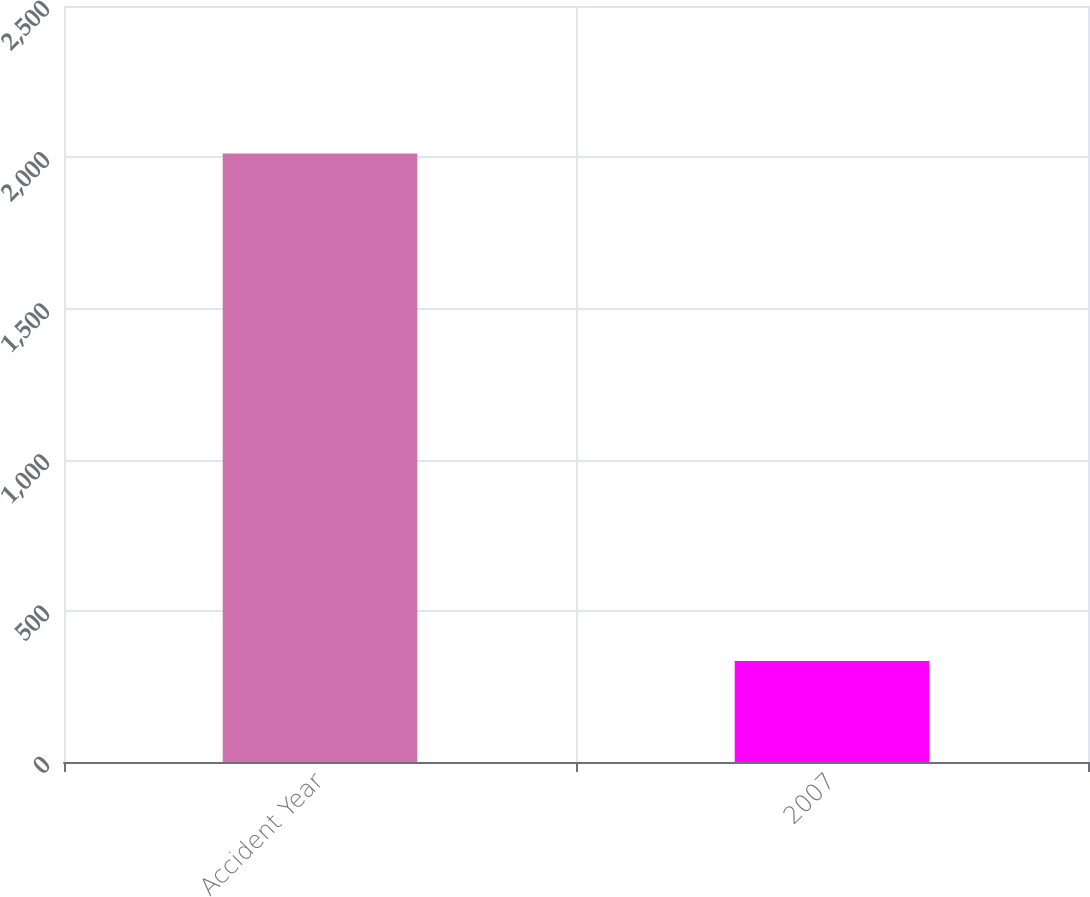Convert chart to OTSL. <chart><loc_0><loc_0><loc_500><loc_500><bar_chart><fcel>Accident Year<fcel>2007<nl><fcel>2012<fcel>334<nl></chart> 